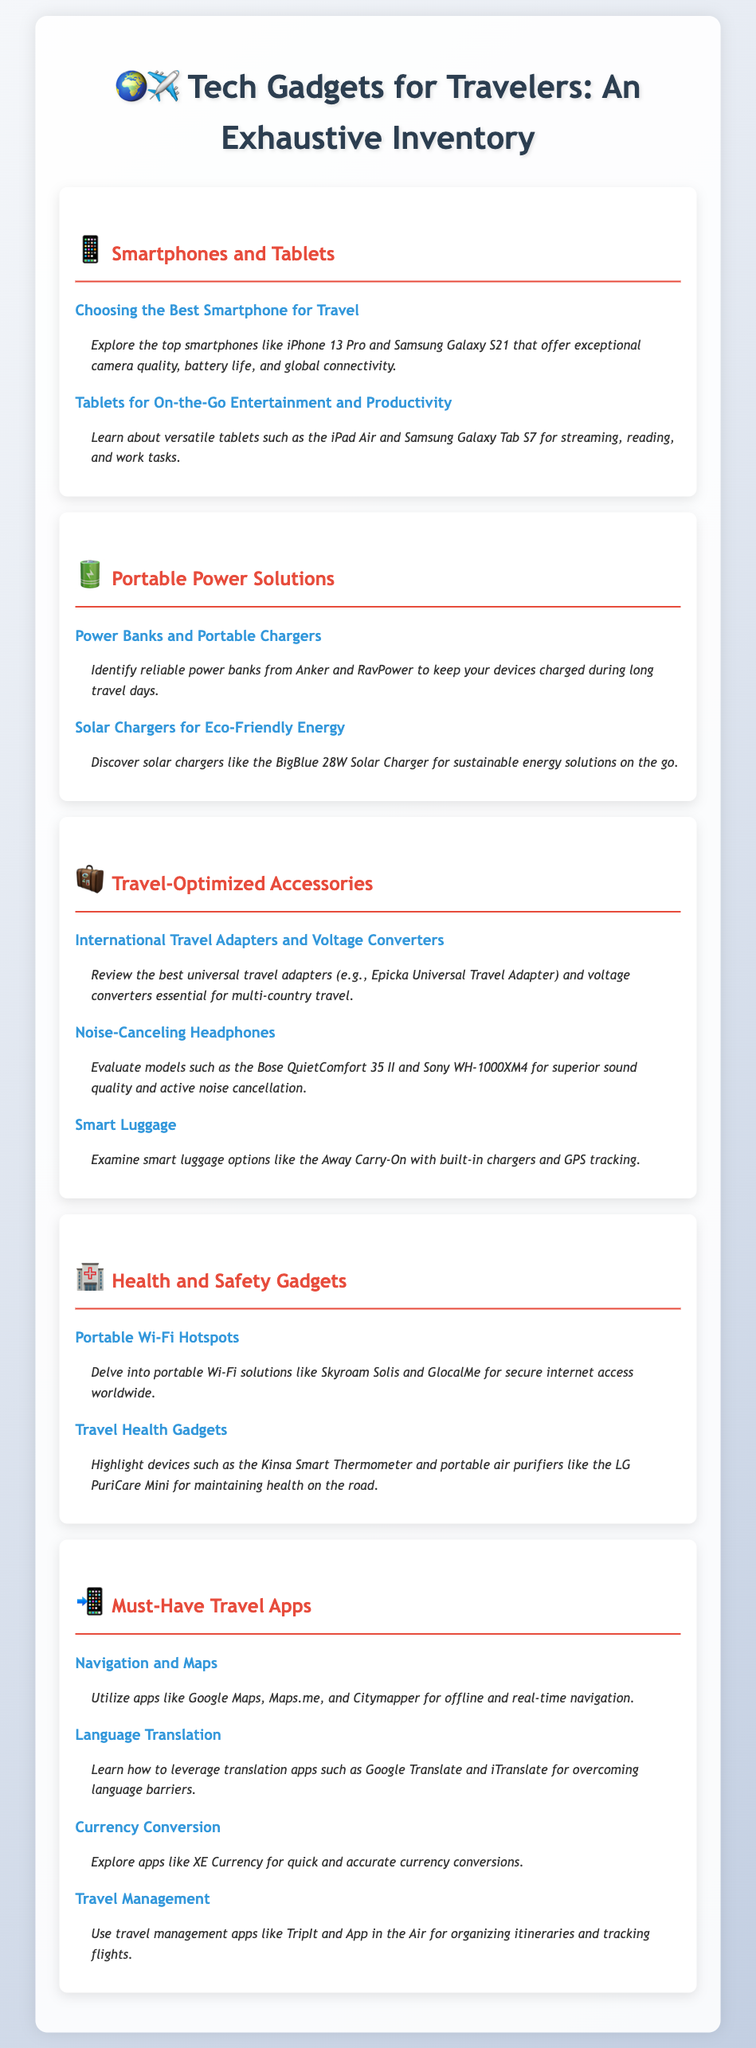What is the title of the syllabus? The title is displayed prominently at the top of the document, indicating the focus on tech gadgets for travelers.
Answer: Tech Gadgets for Travelers: An Exhaustive Inventory Which smartphone is mentioned as having exceptional camera quality? The syllabus lists specific smartphones known for their features, including camera quality.
Answer: iPhone 13 Pro What type of charger is the BigBlue 28W? The syllabus provides details about various chargers, including the characteristics of the BigBlue 28W.
Answer: Solar charger What is evaluated under Travel-Optimized Accessories? The syllabus includes a section that reviews key accessories for travelers, indicating which categories are examined.
Answer: International Travel Adapters and Voltage Converters Which app is suggested for offline navigation? The syllabus lists specific apps designed to assist travelers in different areas, including navigation.
Answer: Google Maps How many models of noise-canceling headphones are referenced? The syllabus provides information about various models of headphones available for travelers to consider.
Answer: Two models What is one of the travel health gadgets highlighted? The syllabus mentions specific health gadgets that are useful for travelers, identifying a particular one.
Answer: Kinsa Smart Thermometer What type of apps are categorized under Must-Have Travel Apps? The syllabus specifies the types of applications deemed essential for enhancing the travel experience.
Answer: Navigation and Maps How many portable Wi-Fi solutions are mentioned? The syllabus outlines different portable Wi-Fi solutions, indicating how many are discussed.
Answer: Two solutions 